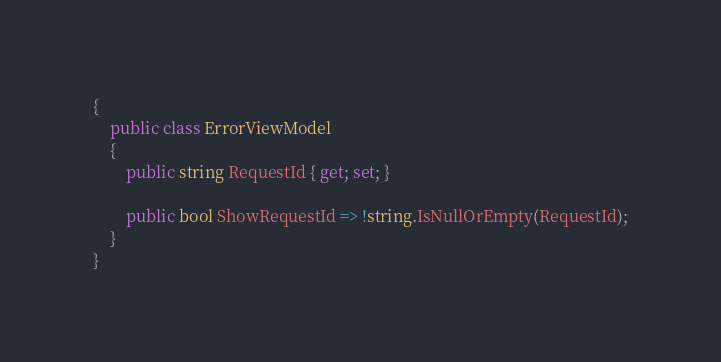Convert code to text. <code><loc_0><loc_0><loc_500><loc_500><_C#_>{
    public class ErrorViewModel
    {
        public string RequestId { get; set; }

        public bool ShowRequestId => !string.IsNullOrEmpty(RequestId);
    }
}</code> 